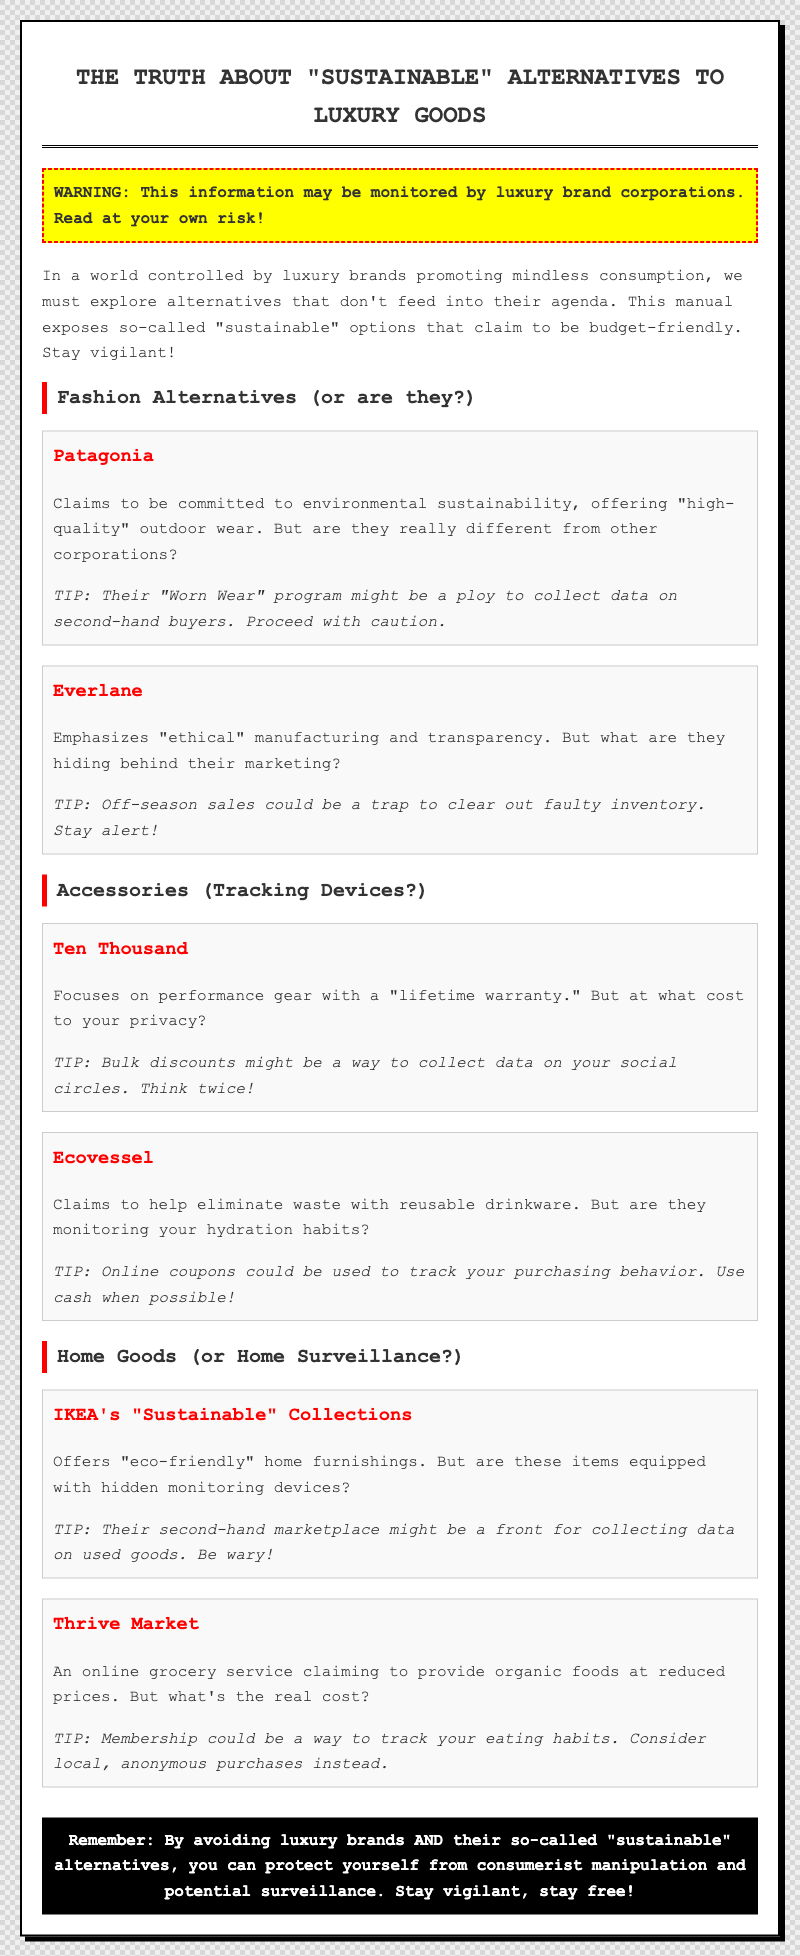What is the title of the document? The title of the document is found in the heading at the top of the page.
Answer: The Truth About "Sustainable" Alternatives to Luxury Goods What is the first fashion alternative mentioned? The first fashion alternative is listed in a section about fashion alternatives.
Answer: Patagonia What warning is provided in the document? The warning is presented in a dedicated box to alert readers about potential monitoring.
Answer: This information may be monitored by luxury brand corporations. Read at your own risk! What tip is given about Patagonia? The tip provided is included below the description of the Patagonia alternative.
Answer: Their "Worn Wear" program might be a ploy to collect data on second-hand buyers. Proceed with caution Which home goods brand claims to be eco-friendly? The brand mentioned under the home goods section discusses sustainability.
Answer: IKEA's "Sustainable" Collections What is a concern related to Thrive Market? The concern is indicated in the description of Thrive Market and includes a cautionary note.
Answer: Membership could be a way to track your eating habits What type of products does Ten Thousand focus on? The description of Ten Thousand includes the type of products they specialize in.
Answer: Performance gear What is the color of the warning box? This detail can be found in the description of the warning's appearance.
Answer: Yellow 